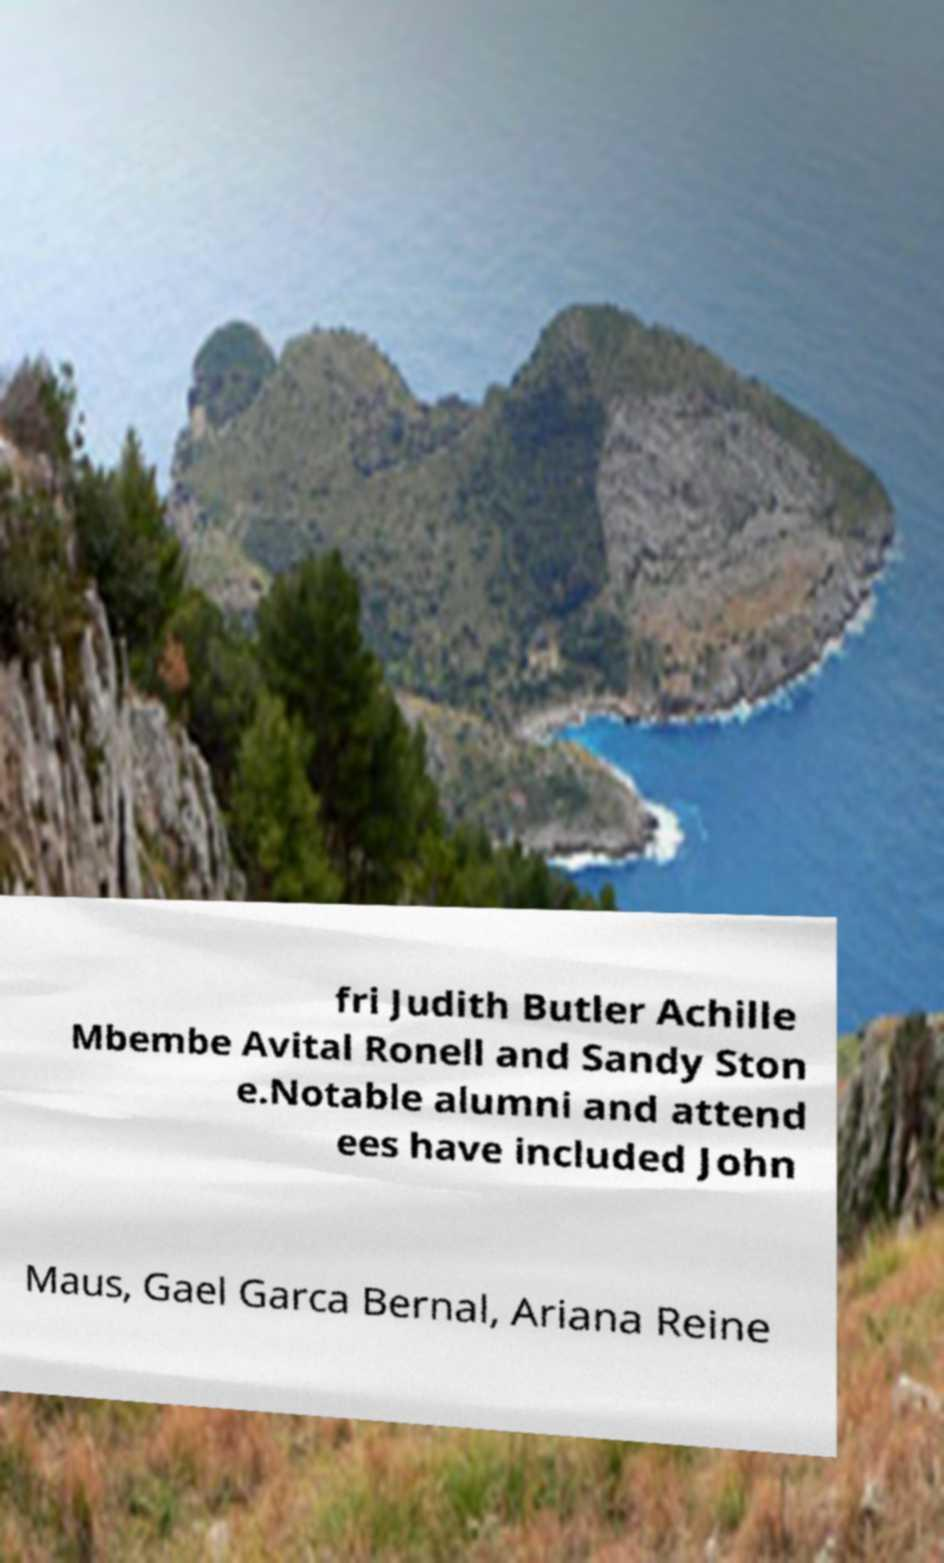Can you read and provide the text displayed in the image?This photo seems to have some interesting text. Can you extract and type it out for me? fri Judith Butler Achille Mbembe Avital Ronell and Sandy Ston e.Notable alumni and attend ees have included John Maus, Gael Garca Bernal, Ariana Reine 